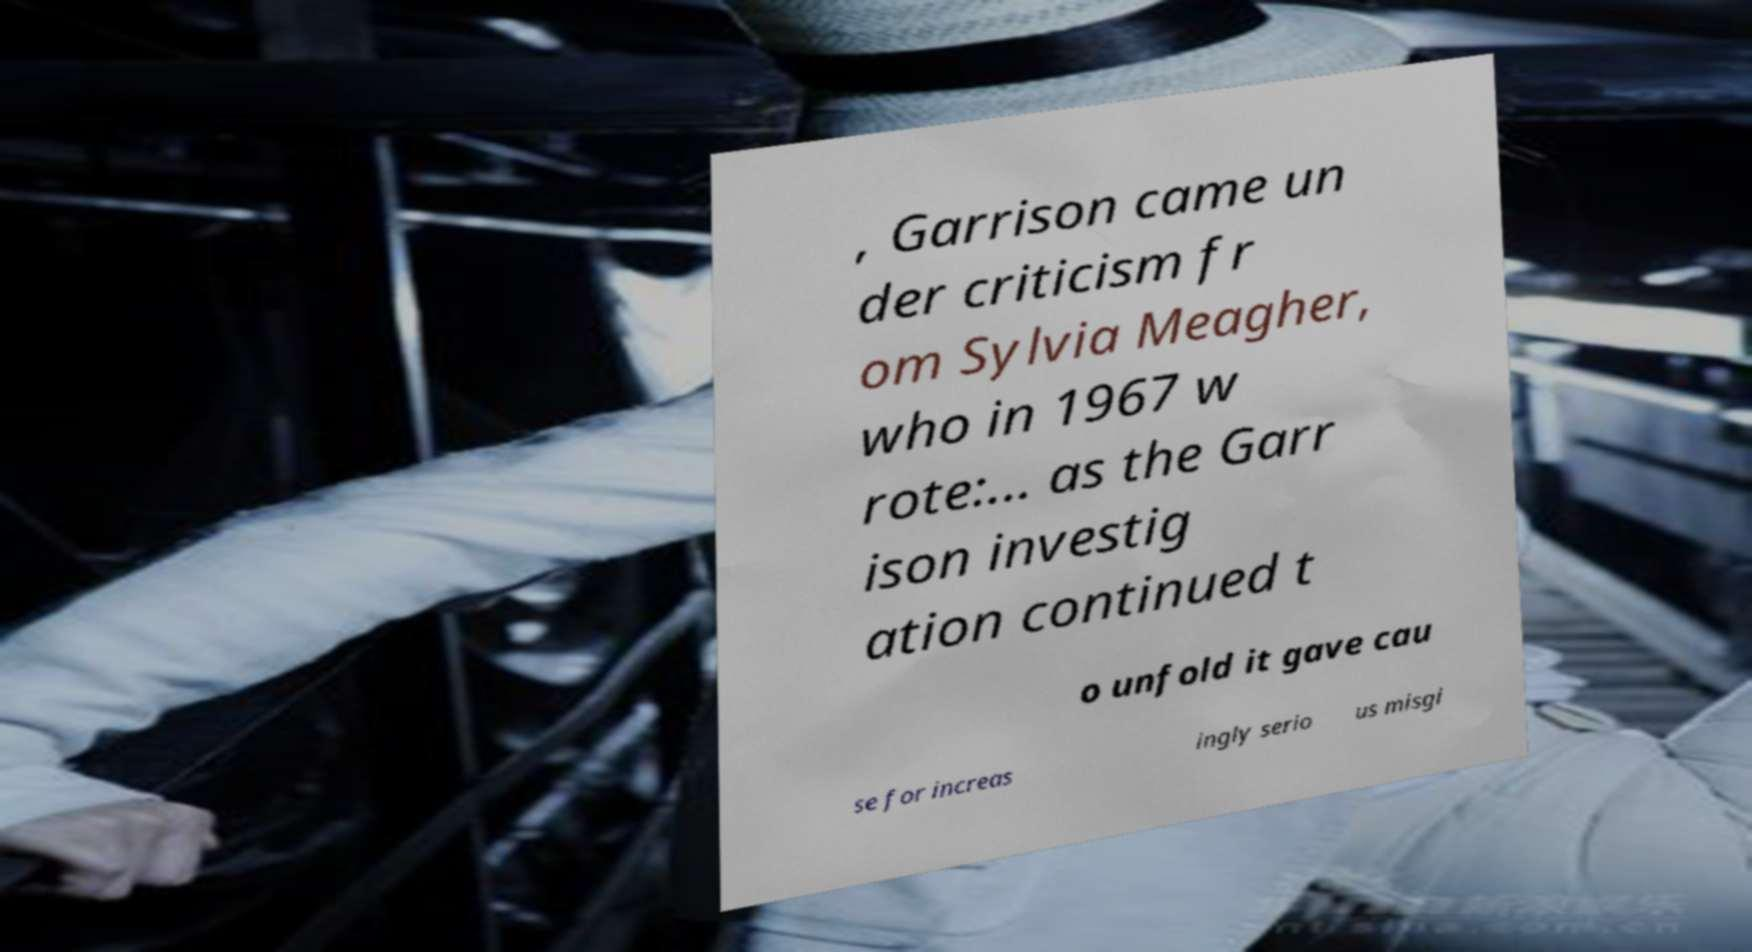Can you read and provide the text displayed in the image?This photo seems to have some interesting text. Can you extract and type it out for me? , Garrison came un der criticism fr om Sylvia Meagher, who in 1967 w rote:... as the Garr ison investig ation continued t o unfold it gave cau se for increas ingly serio us misgi 